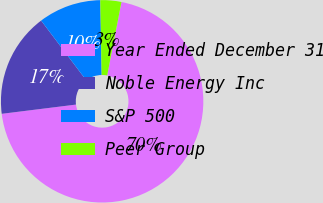Convert chart to OTSL. <chart><loc_0><loc_0><loc_500><loc_500><pie_chart><fcel>Year Ended December 31<fcel>Noble Energy Inc<fcel>S&P 500<fcel>Peer Group<nl><fcel>69.97%<fcel>16.67%<fcel>10.01%<fcel>3.35%<nl></chart> 